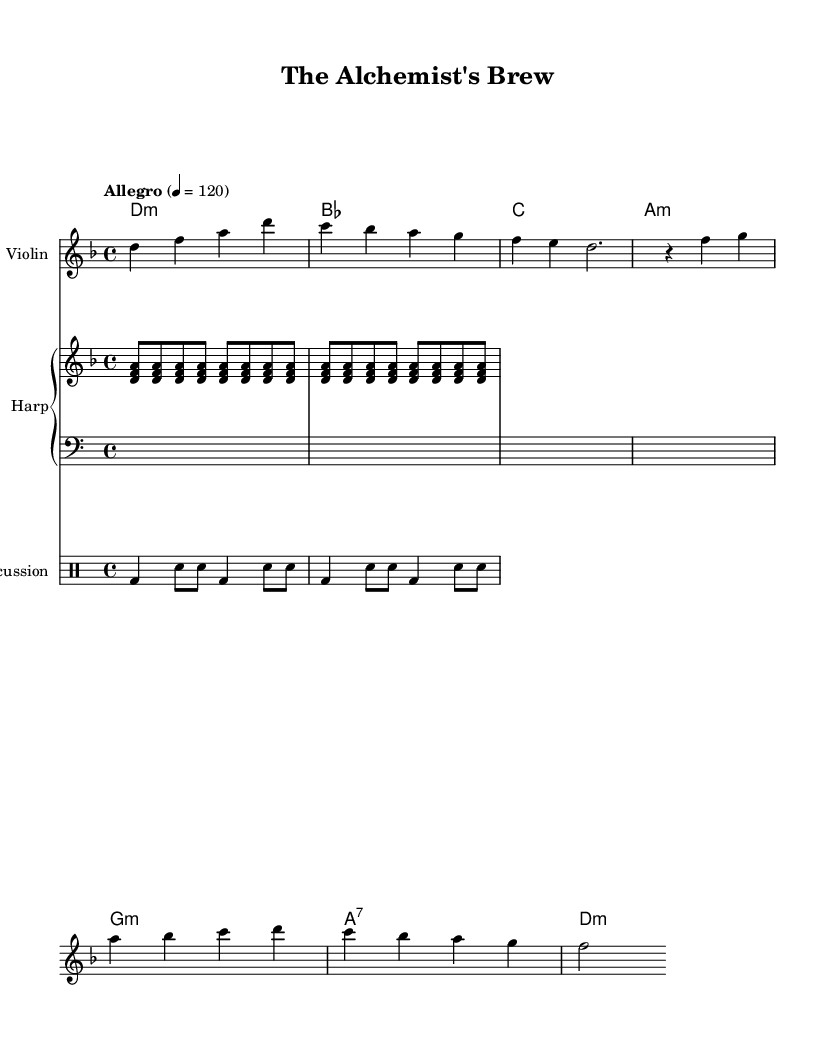What is the key signature of this music? The key signature is indicated at the beginning of the staff, showing two flats, which corresponds to B flat and E flat. This identifies the piece as being in D minor.
Answer: D minor What is the time signature of this music? The time signature is displayed at the beginning of the score as "4/4," which indicates four beats in a measure, with each quarter note receiving one beat.
Answer: 4/4 What is the tempo marking of this piece? The tempo marking, noted at the beginning of the score, reads "Allegro" with a metronome marking of "4 = 120," indicating that there should be a lively and fast-paced performance at 120 beats per minute.
Answer: Allegro How many measures are there in the Violin part? By counting the individual measures in the Violin part, there are a total of four measures, which can be visually counted from the beginning to the end of the provided score for that instrument.
Answer: 4 What chord is played at the beginning of the piece? The chord at the beginning is indicated in the chord names section as "d:m," which represents a D minor chord featuring the notes D, F, and A.
Answer: D minor Which instrument plays the chord arpeggios? The instrument performing the chord arpeggios is the Harp, as indicated in the instrument name tagged in the score and by its sequence of arpeggiated chords played in the higher range.
Answer: Harp 